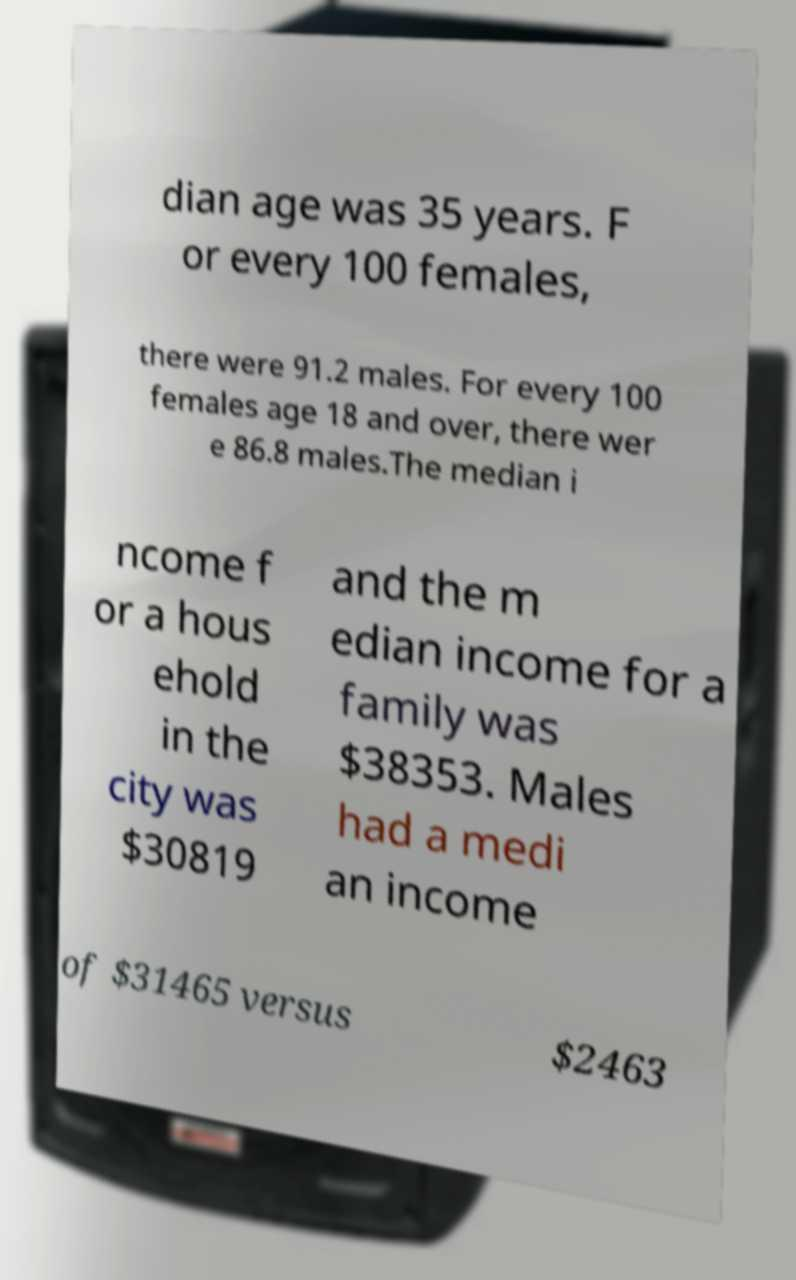There's text embedded in this image that I need extracted. Can you transcribe it verbatim? dian age was 35 years. F or every 100 females, there were 91.2 males. For every 100 females age 18 and over, there wer e 86.8 males.The median i ncome f or a hous ehold in the city was $30819 and the m edian income for a family was $38353. Males had a medi an income of $31465 versus $2463 